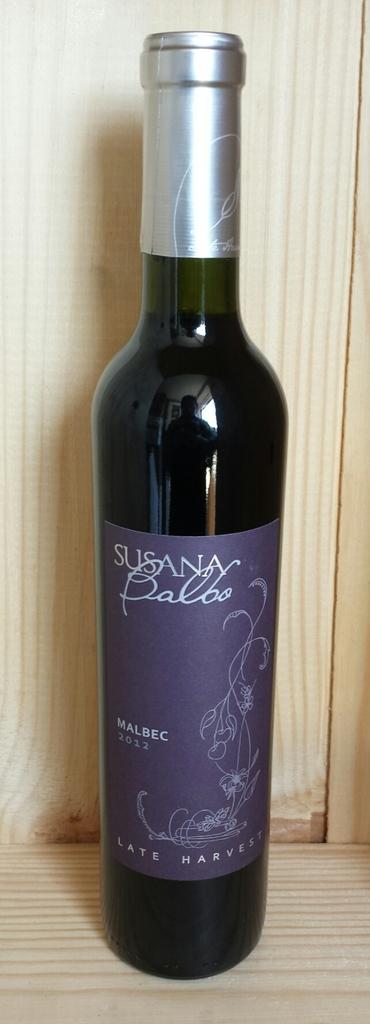What kind of wine is this?
Your answer should be compact. Susana palbo. What company makes this wine?
Provide a succinct answer. Susana balbo. 